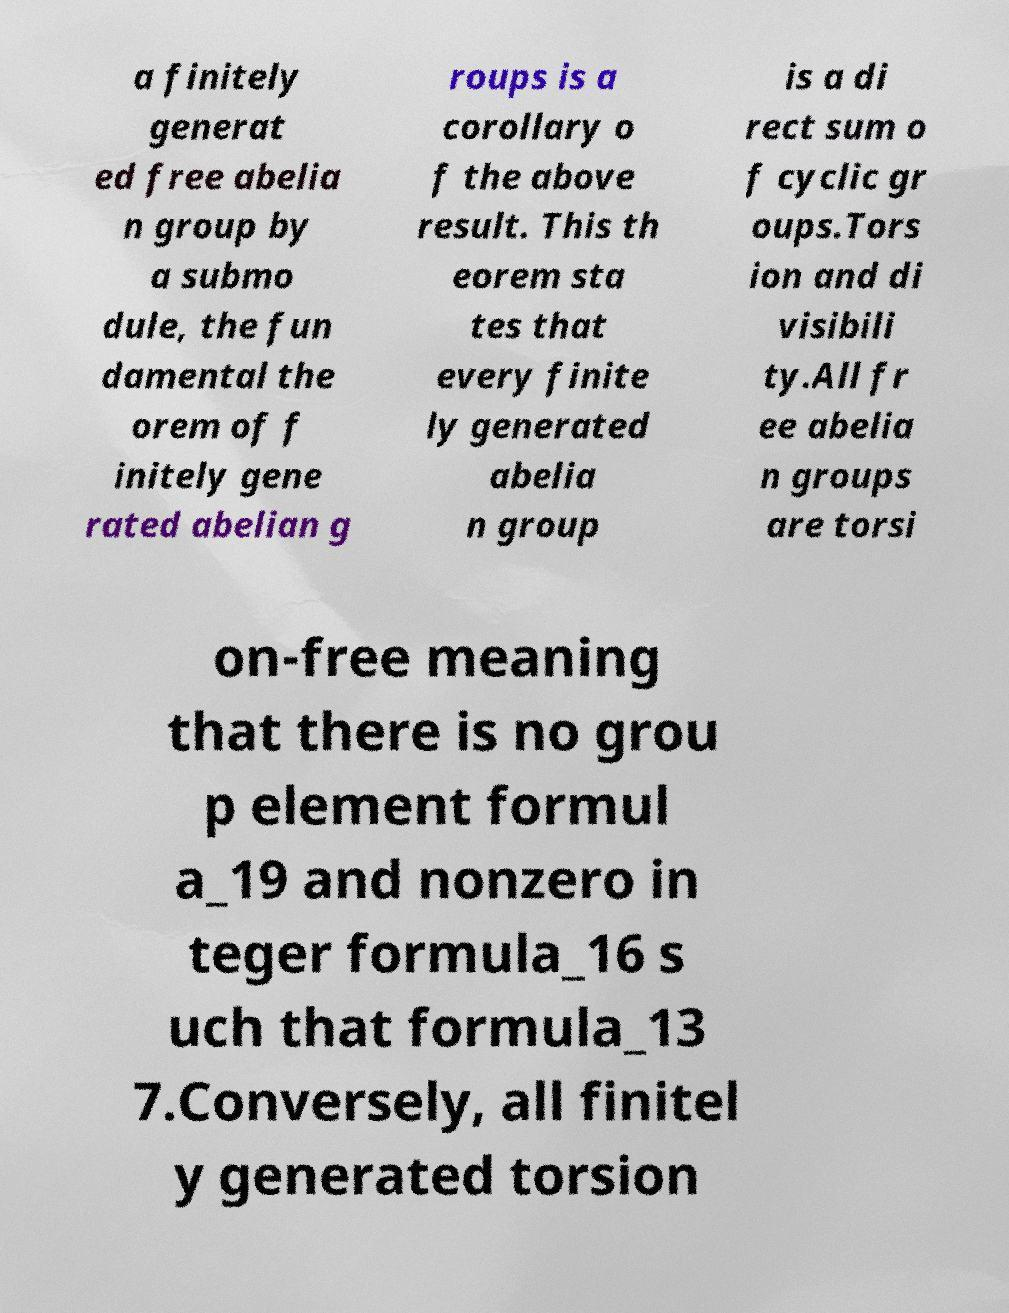There's text embedded in this image that I need extracted. Can you transcribe it verbatim? a finitely generat ed free abelia n group by a submo dule, the fun damental the orem of f initely gene rated abelian g roups is a corollary o f the above result. This th eorem sta tes that every finite ly generated abelia n group is a di rect sum o f cyclic gr oups.Tors ion and di visibili ty.All fr ee abelia n groups are torsi on-free meaning that there is no grou p element formul a_19 and nonzero in teger formula_16 s uch that formula_13 7.Conversely, all finitel y generated torsion 